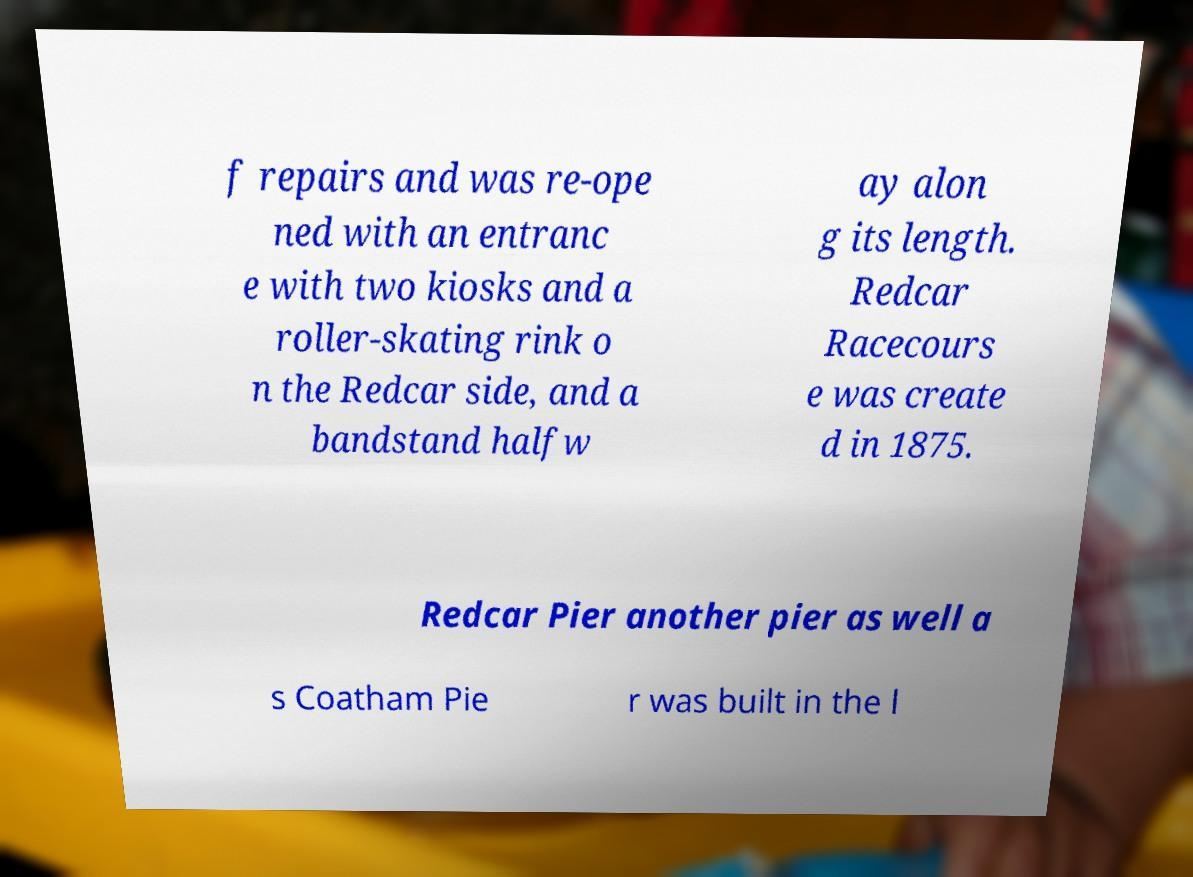Can you accurately transcribe the text from the provided image for me? f repairs and was re-ope ned with an entranc e with two kiosks and a roller-skating rink o n the Redcar side, and a bandstand halfw ay alon g its length. Redcar Racecours e was create d in 1875. Redcar Pier another pier as well a s Coatham Pie r was built in the l 